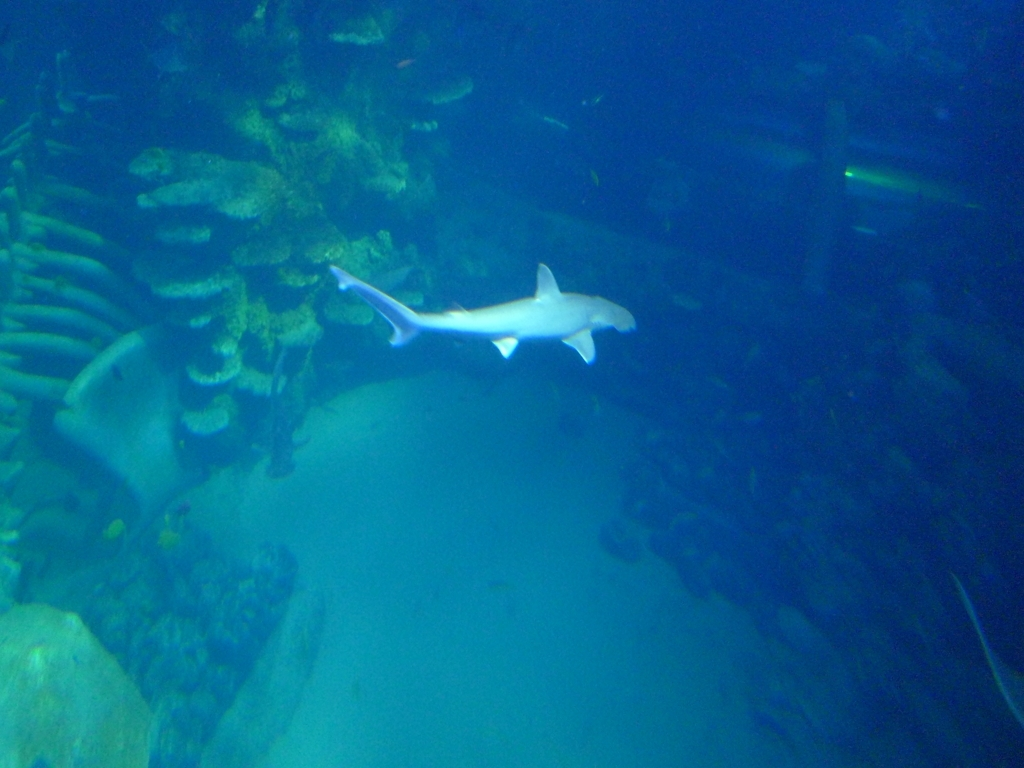What are the challenges of taking photographs in this kind of environment? Underwater photography faces several challenges, including limited natural lighting, which can lead to a blue tint in the photos due to the water's selective absorption of light wavelengths. The water also affects clarity, as particles can cause backscatter. Additionally, the photographer must deal with movement from both the water currents and marine life, which can result in motion blur unless a fast shutter speed is used. 